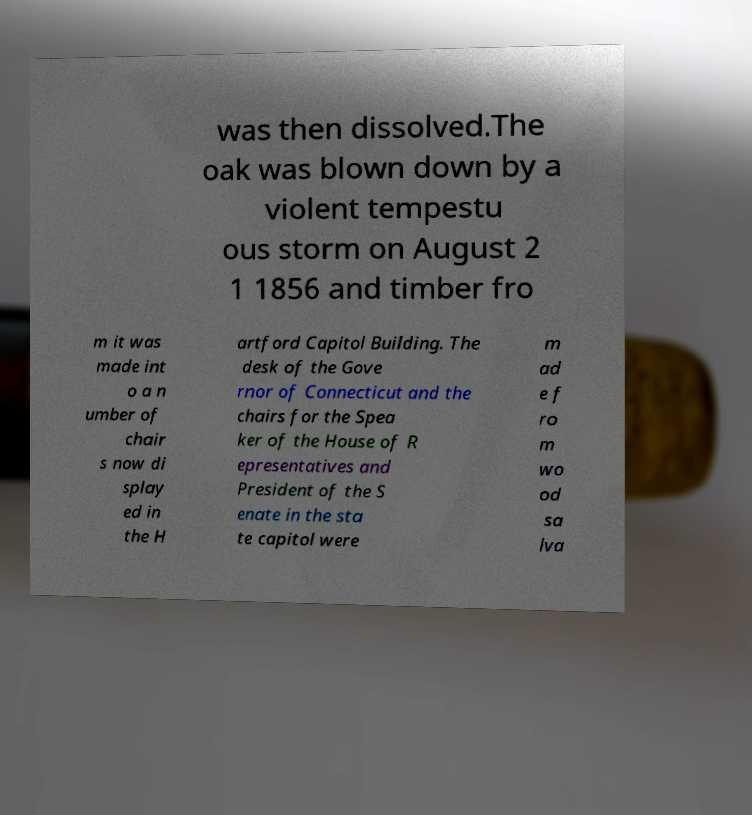Please identify and transcribe the text found in this image. was then dissolved.The oak was blown down by a violent tempestu ous storm on August 2 1 1856 and timber fro m it was made int o a n umber of chair s now di splay ed in the H artford Capitol Building. The desk of the Gove rnor of Connecticut and the chairs for the Spea ker of the House of R epresentatives and President of the S enate in the sta te capitol were m ad e f ro m wo od sa lva 